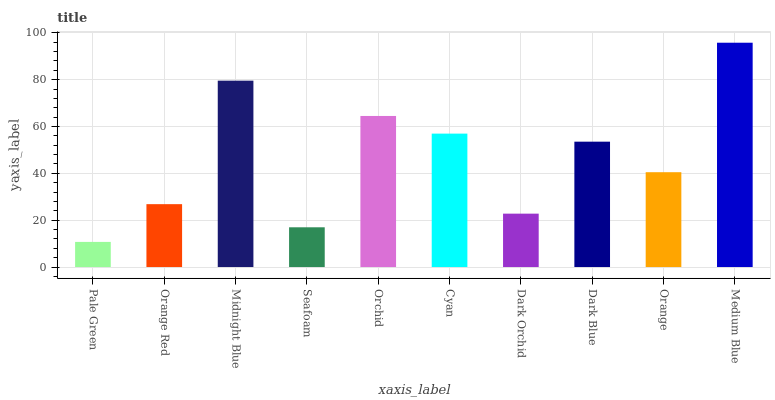Is Orange Red the minimum?
Answer yes or no. No. Is Orange Red the maximum?
Answer yes or no. No. Is Orange Red greater than Pale Green?
Answer yes or no. Yes. Is Pale Green less than Orange Red?
Answer yes or no. Yes. Is Pale Green greater than Orange Red?
Answer yes or no. No. Is Orange Red less than Pale Green?
Answer yes or no. No. Is Dark Blue the high median?
Answer yes or no. Yes. Is Orange the low median?
Answer yes or no. Yes. Is Orange Red the high median?
Answer yes or no. No. Is Medium Blue the low median?
Answer yes or no. No. 